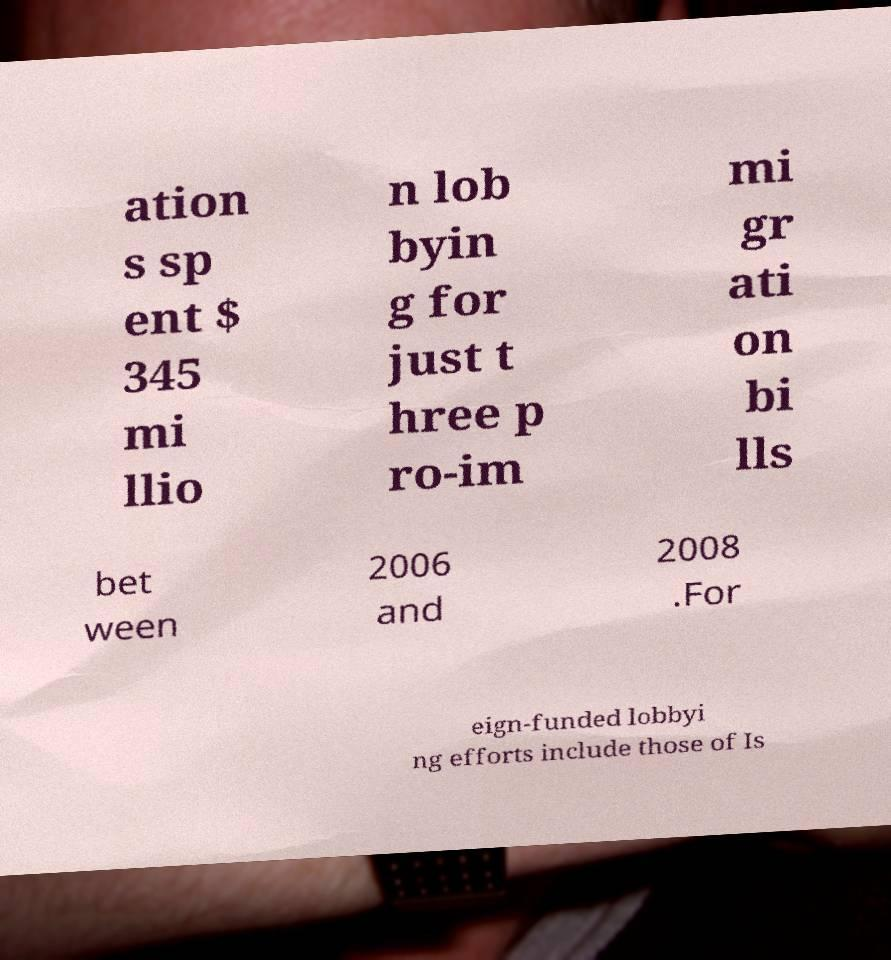For documentation purposes, I need the text within this image transcribed. Could you provide that? ation s sp ent $ 345 mi llio n lob byin g for just t hree p ro-im mi gr ati on bi lls bet ween 2006 and 2008 .For eign-funded lobbyi ng efforts include those of Is 